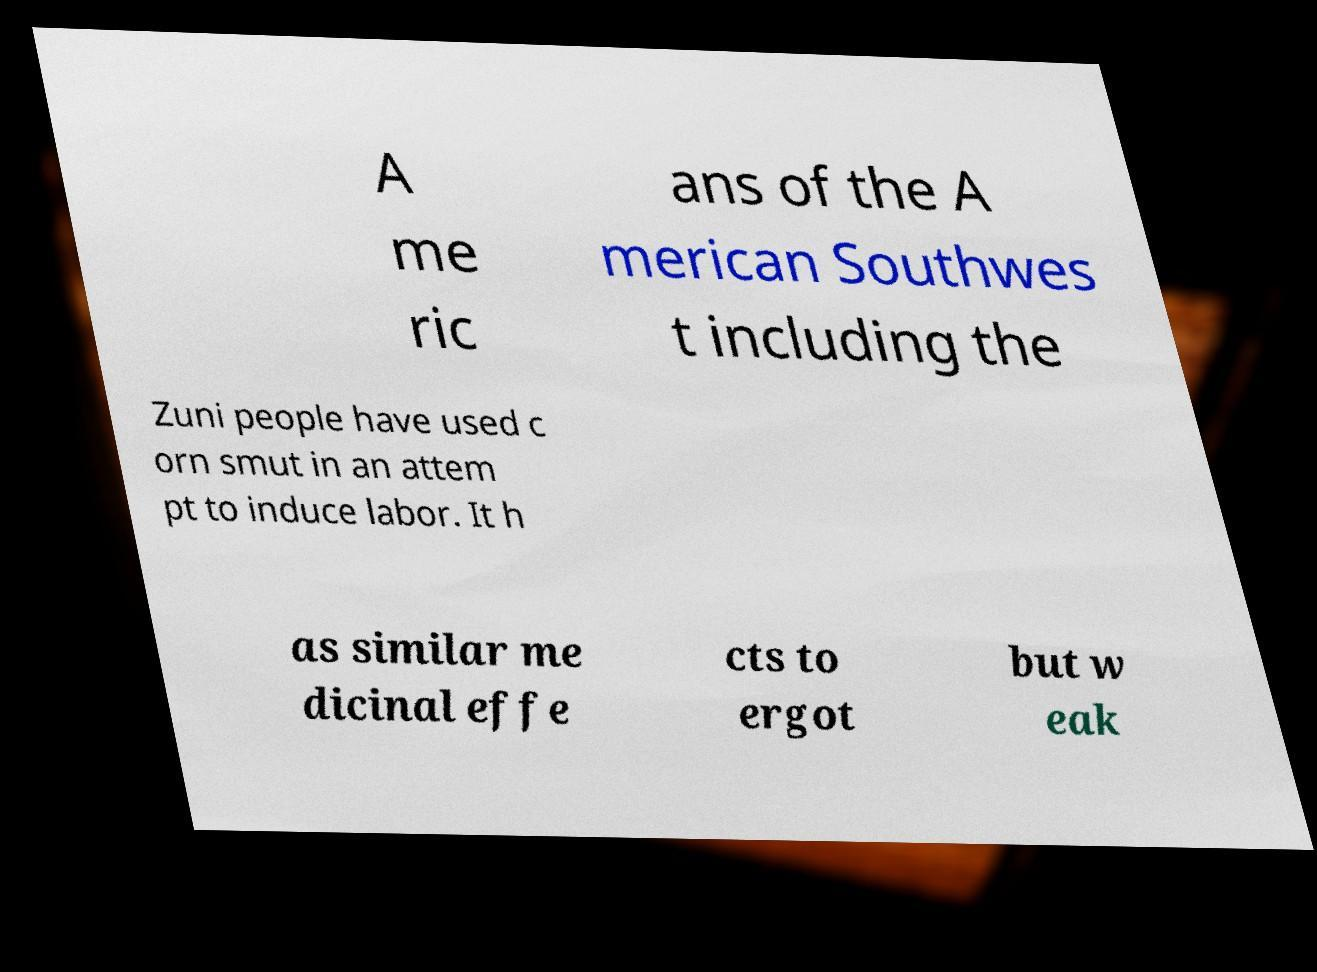For documentation purposes, I need the text within this image transcribed. Could you provide that? A me ric ans of the A merican Southwes t including the Zuni people have used c orn smut in an attem pt to induce labor. It h as similar me dicinal effe cts to ergot but w eak 